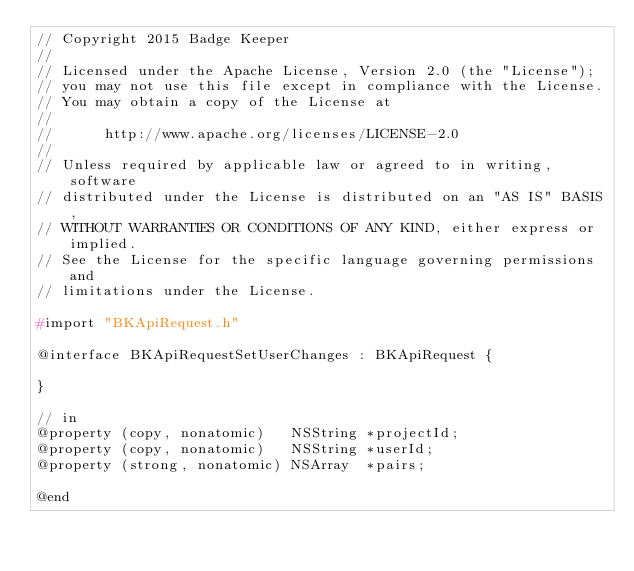Convert code to text. <code><loc_0><loc_0><loc_500><loc_500><_C_>// Copyright 2015 Badge Keeper
//
// Licensed under the Apache License, Version 2.0 (the "License");
// you may not use this file except in compliance with the License.
// You may obtain a copy of the License at
//
//      http://www.apache.org/licenses/LICENSE-2.0
//
// Unless required by applicable law or agreed to in writing, software
// distributed under the License is distributed on an "AS IS" BASIS,
// WITHOUT WARRANTIES OR CONDITIONS OF ANY KIND, either express or implied.
// See the License for the specific language governing permissions and
// limitations under the License.

#import "BKApiRequest.h"

@interface BKApiRequestSetUserChanges : BKApiRequest {
    
}

// in
@property (copy, nonatomic)   NSString *projectId;
@property (copy, nonatomic)   NSString *userId;
@property (strong, nonatomic) NSArray  *pairs;

@end
</code> 